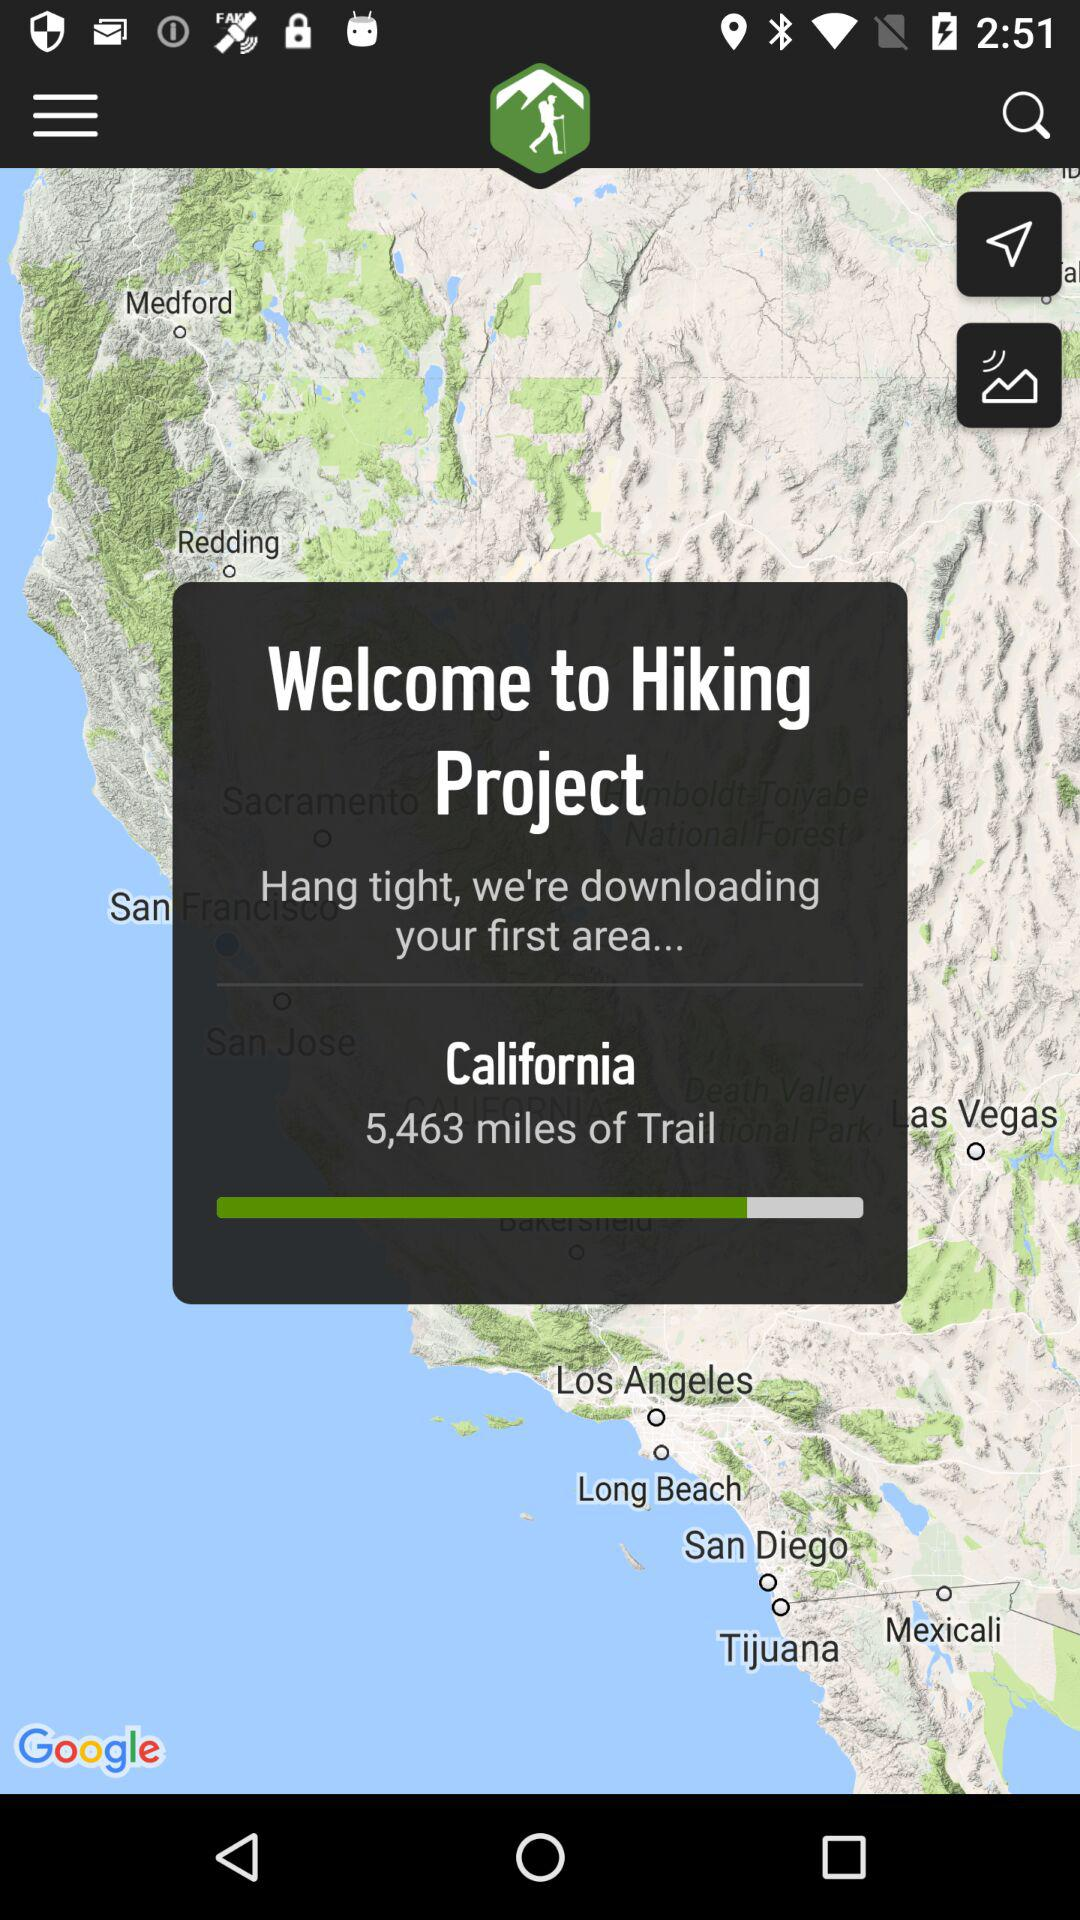How long does it take to hike the trail?
When the provided information is insufficient, respond with <no answer>. <no answer> 